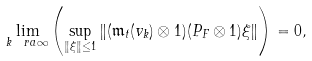Convert formula to latex. <formula><loc_0><loc_0><loc_500><loc_500>\lim _ { k \ r a \infty } \left ( \sup _ { \| \xi \| \leq 1 } \| ( \mathfrak m _ { t } ( v _ { k } ) \otimes 1 ) ( P _ { F } \otimes 1 ) \xi \| \right ) = 0 ,</formula> 